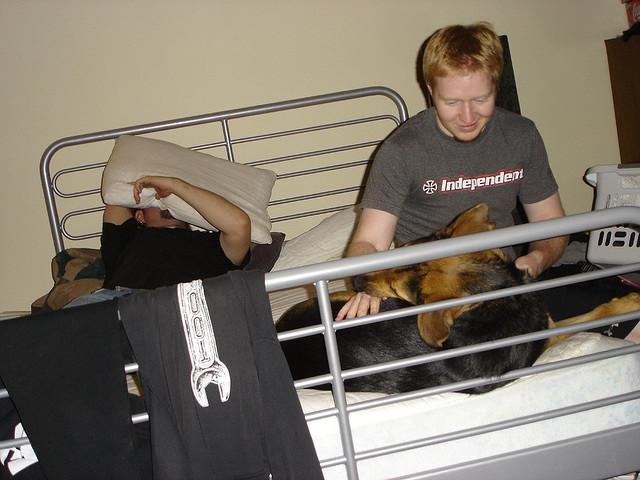How many people are in the picture?
Give a very brief answer. 2. How many people are in the photo?
Give a very brief answer. 2. 